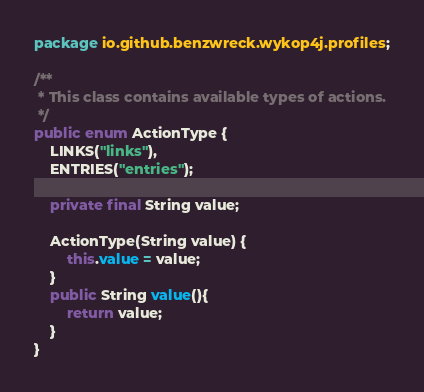Convert code to text. <code><loc_0><loc_0><loc_500><loc_500><_Java_>package io.github.benzwreck.wykop4j.profiles;

/**
 * This class contains available types of actions.
 */
public enum ActionType {
    LINKS("links"),
    ENTRIES("entries");

    private final String value;

    ActionType(String value) {
        this.value = value;
    }
    public String value(){
        return value;
    }
}
</code> 